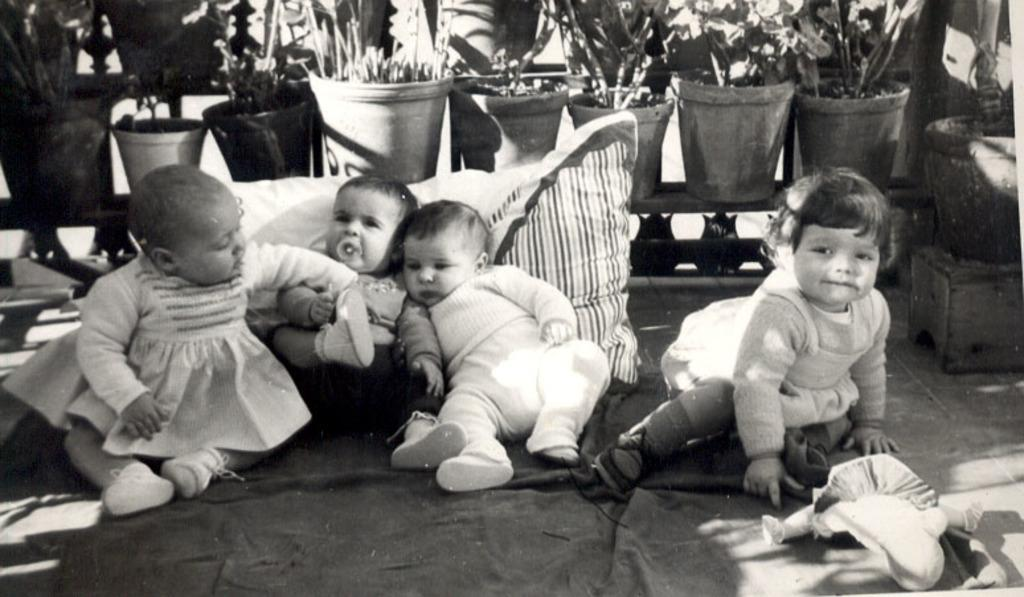How many babies are present in the image? There are four babies in the image. What can be seen in the image besides the babies? There is a pillow, a toy, flower pots, plants, some unspecified objects, and a carpet at the bottom of the image. What type of object is used for sitting or lying on in the image? The pillow is an object used for sitting or lying on in the image. What type of object is used for playing in the image? The toy is an object used for playing in the image. What type of objects are used for decoration or gardening in the image? The flower pots and plants are objects used for decoration or gardening in the image. What type of bait is used to catch fish in the image? There is no mention of fish or bait in the image; it features four babies, a pillow, a toy, flower pots, plants, unspecified objects, and a carpet. What type of blade is used for cutting in the image? There is no blade present in the image. 